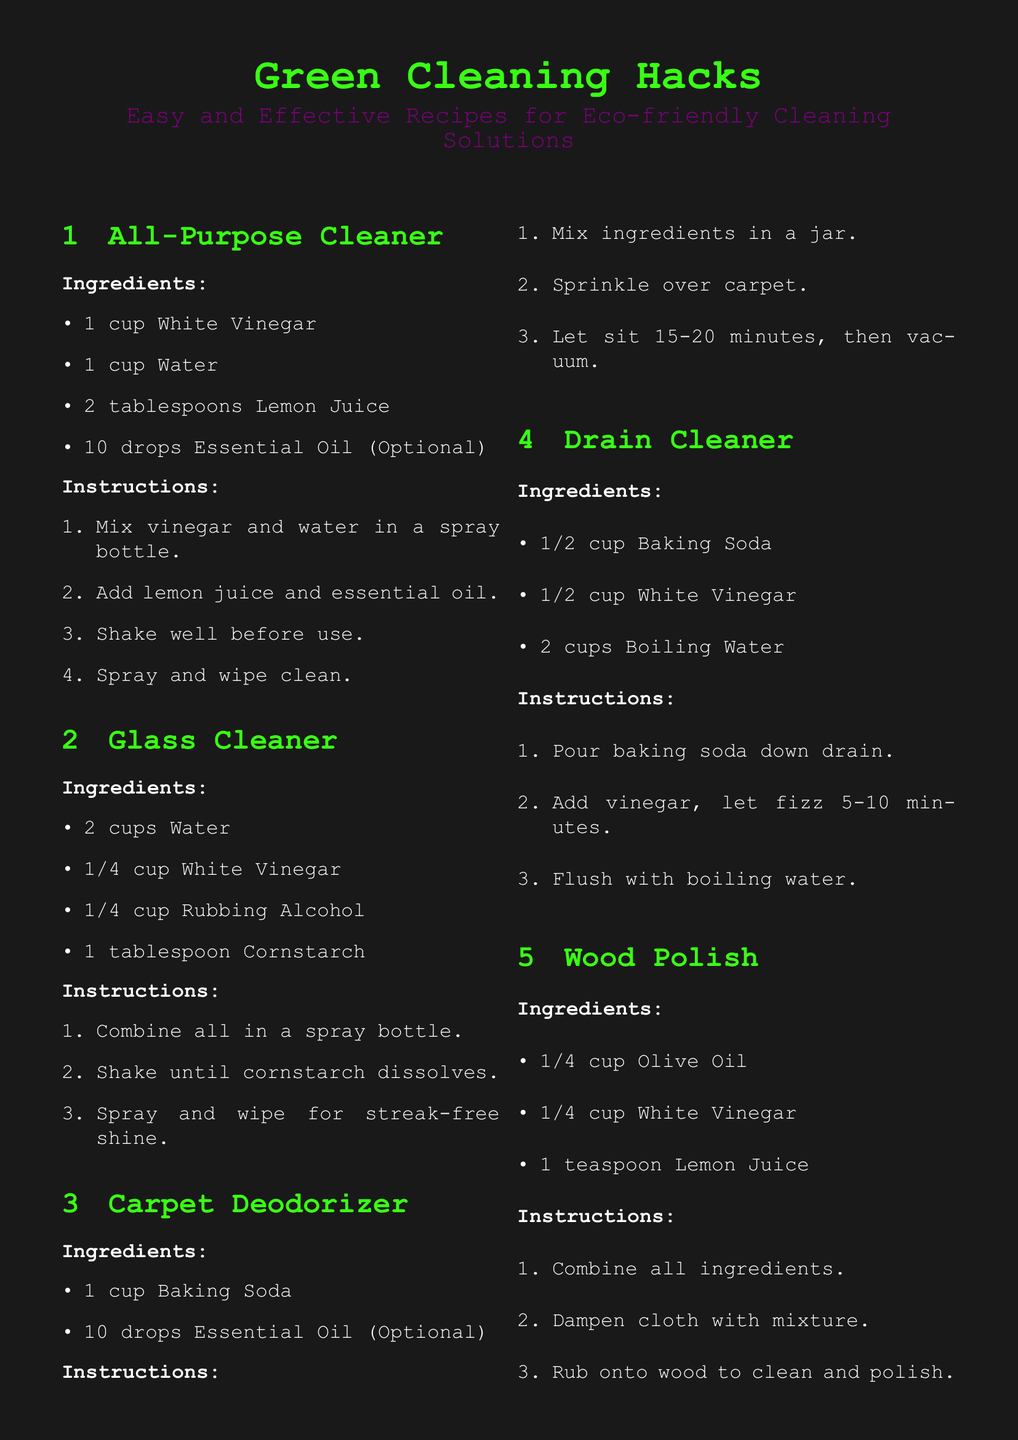what are the ingredients of the All-Purpose Cleaner? The ingredients include White Vinegar, Water, Lemon Juice, and Essential Oil.
Answer: White Vinegar, Water, Lemon Juice, Essential Oil how much Water is needed for the Glass Cleaner? The recipe specifies 2 cups of Water for the Glass Cleaner.
Answer: 2 cups what is the key function of Baking Soda in the Drain Cleaner recipe? Baking Soda is used to create a fizz when combined with vinegar, helping to clean the drain.
Answer: fizz how long should you let the Carpet Deodorizer sit before vacuuming? The document mentions letting the Carpet Deodorizer sit for 15-20 minutes.
Answer: 15-20 minutes what common household item is used as the primary base for the Wood Polish? Olive Oil is highlighted as the main ingredient in the Wood Polish recipe.
Answer: Olive Oil what is the final message on the document? The document concludes with a catchy phrase emphasizing the eco-friendly approach to cleaning.
Answer: Clean Green, Rock On! how many total recipes are provided in the document? The document lists five different green cleaning recipes.
Answer: five what is the optional ingredient in the All-Purpose Cleaner? Essential Oil is mentioned as an optional ingredient in the All-Purpose Cleaner.
Answer: Essential Oil what cleaning solution is made with Rubbing Alcohol? The Glass Cleaner recipe includes Rubbing Alcohol as one of its ingredients.
Answer: Glass Cleaner 